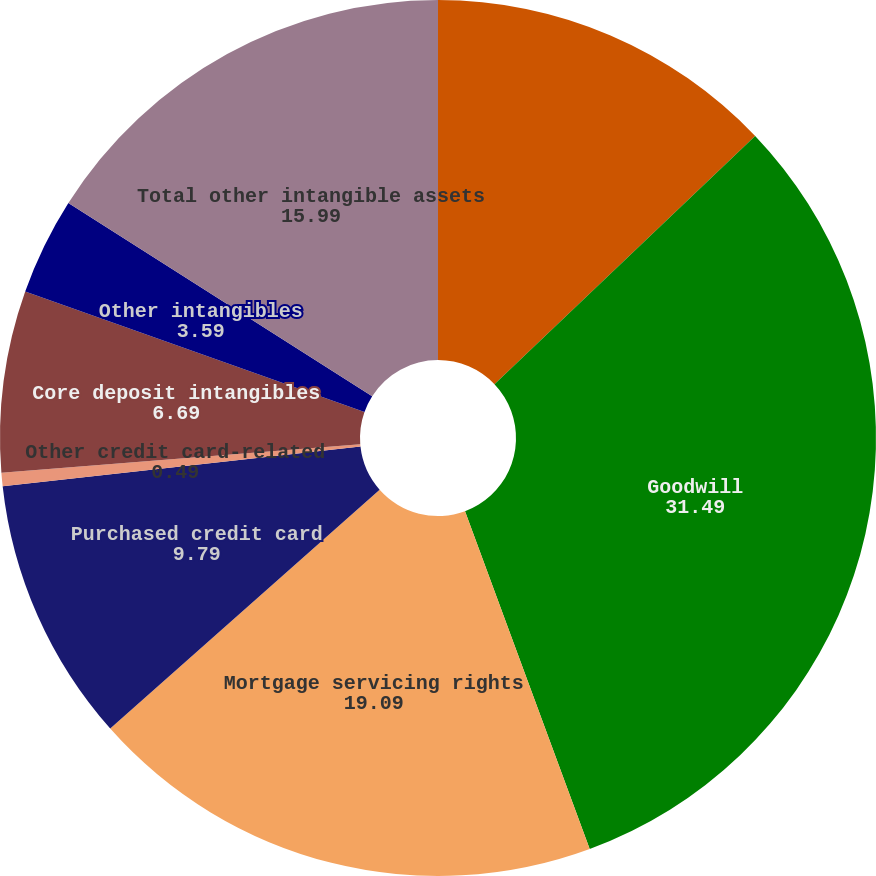Convert chart. <chart><loc_0><loc_0><loc_500><loc_500><pie_chart><fcel>December 31 (in millions)<fcel>Goodwill<fcel>Mortgage servicing rights<fcel>Purchased credit card<fcel>Other credit card-related<fcel>Core deposit intangibles<fcel>Other intangibles<fcel>Total other intangible assets<nl><fcel>12.89%<fcel>31.49%<fcel>19.09%<fcel>9.79%<fcel>0.49%<fcel>6.69%<fcel>3.59%<fcel>15.99%<nl></chart> 